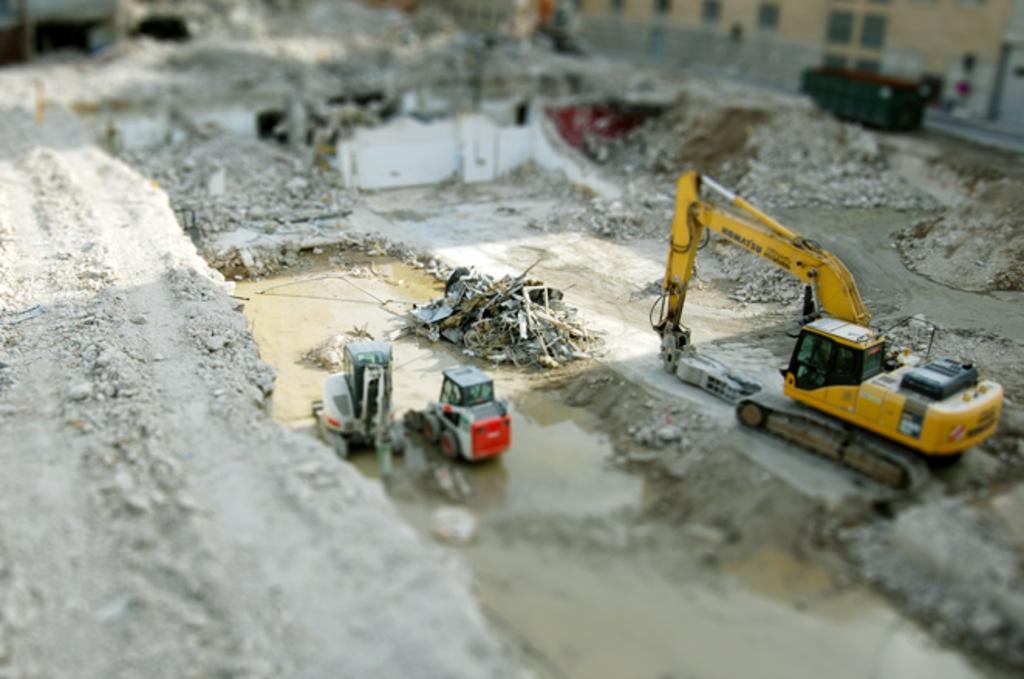Can you describe this image briefly? In this picture we can see few earth moving vehicles and houses. 